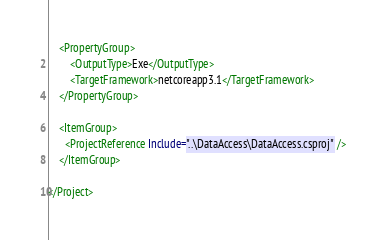Convert code to text. <code><loc_0><loc_0><loc_500><loc_500><_XML_>
    <PropertyGroup>
        <OutputType>Exe</OutputType>
        <TargetFramework>netcoreapp3.1</TargetFramework>
    </PropertyGroup>

    <ItemGroup>
      <ProjectReference Include="..\DataAccess\DataAccess.csproj" />
    </ItemGroup>

</Project>
</code> 